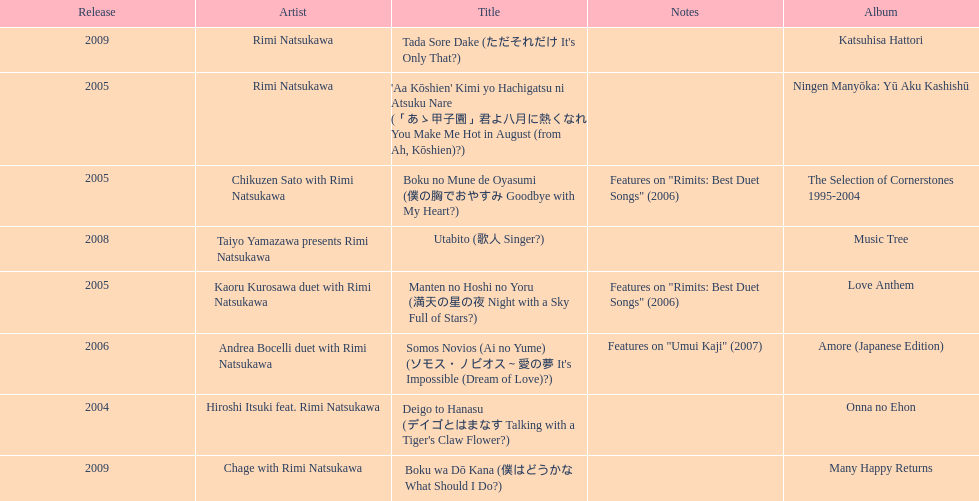What song was this artist on after utabito? Boku wa Dō Kana. 